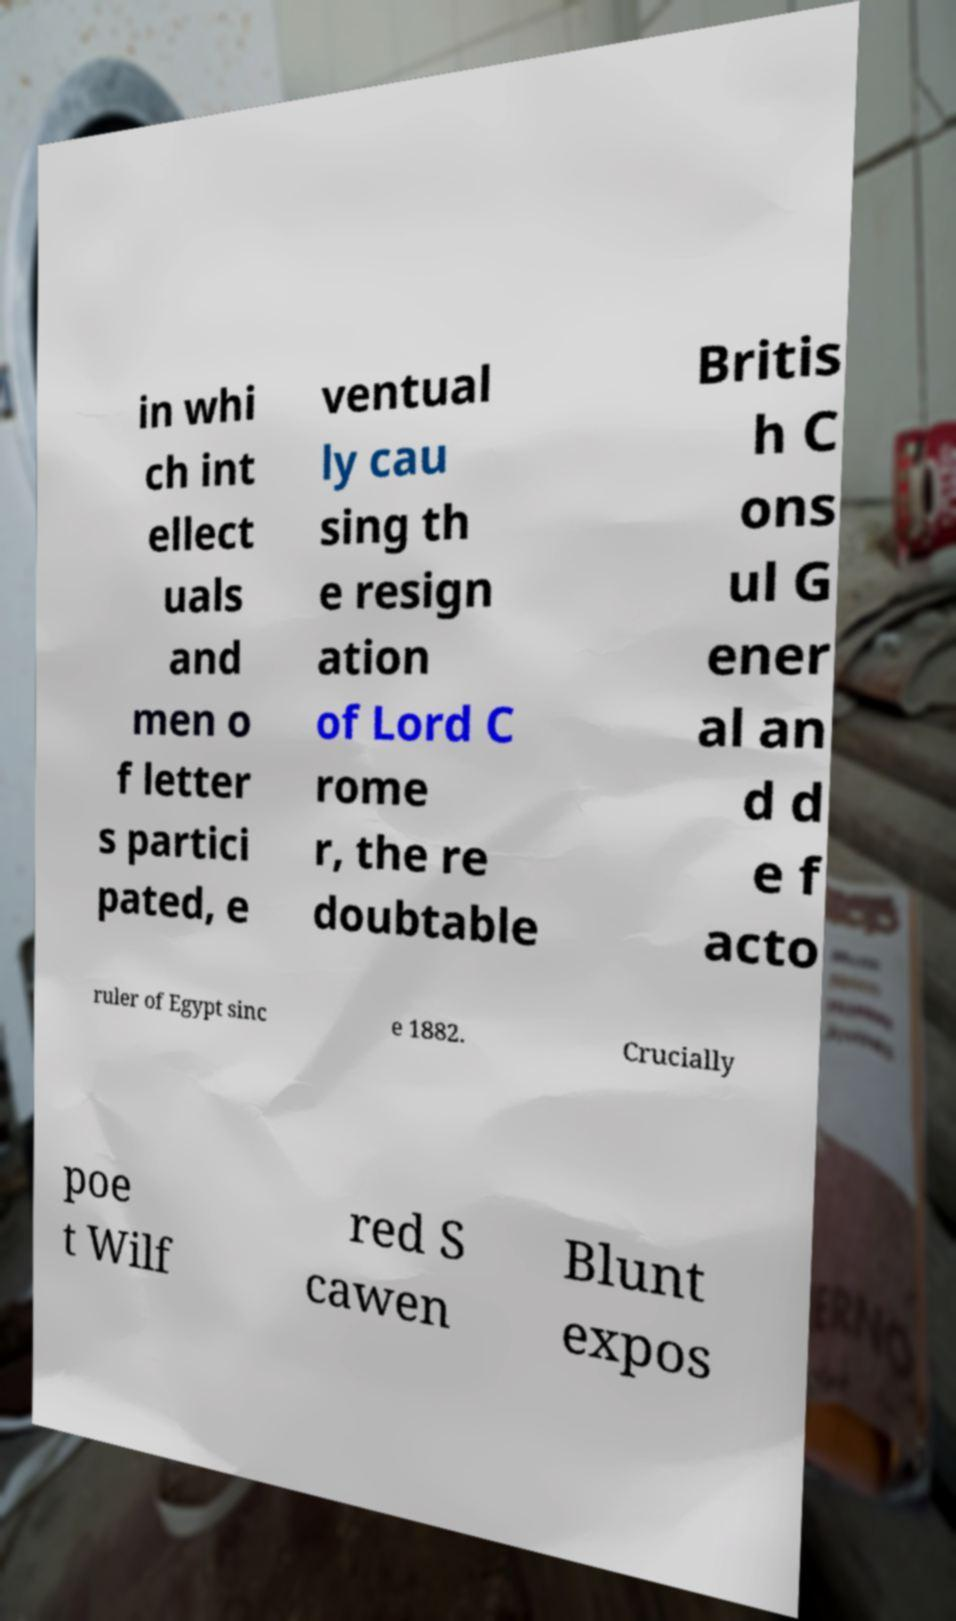Can you read and provide the text displayed in the image?This photo seems to have some interesting text. Can you extract and type it out for me? in whi ch int ellect uals and men o f letter s partici pated, e ventual ly cau sing th e resign ation of Lord C rome r, the re doubtable Britis h C ons ul G ener al an d d e f acto ruler of Egypt sinc e 1882. Crucially poe t Wilf red S cawen Blunt expos 